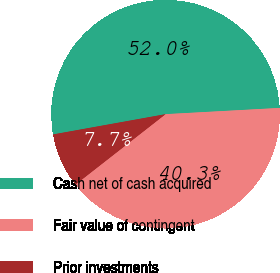<chart> <loc_0><loc_0><loc_500><loc_500><pie_chart><fcel>Cash net of cash acquired<fcel>Fair value of contingent<fcel>Prior investments<nl><fcel>51.97%<fcel>40.31%<fcel>7.72%<nl></chart> 